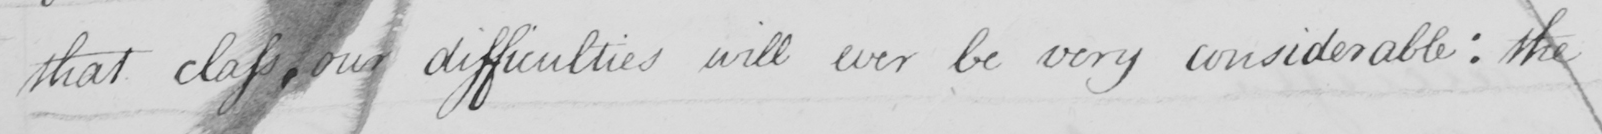What text is written in this handwritten line? that class, our difficulties will ever be very considerable: the 